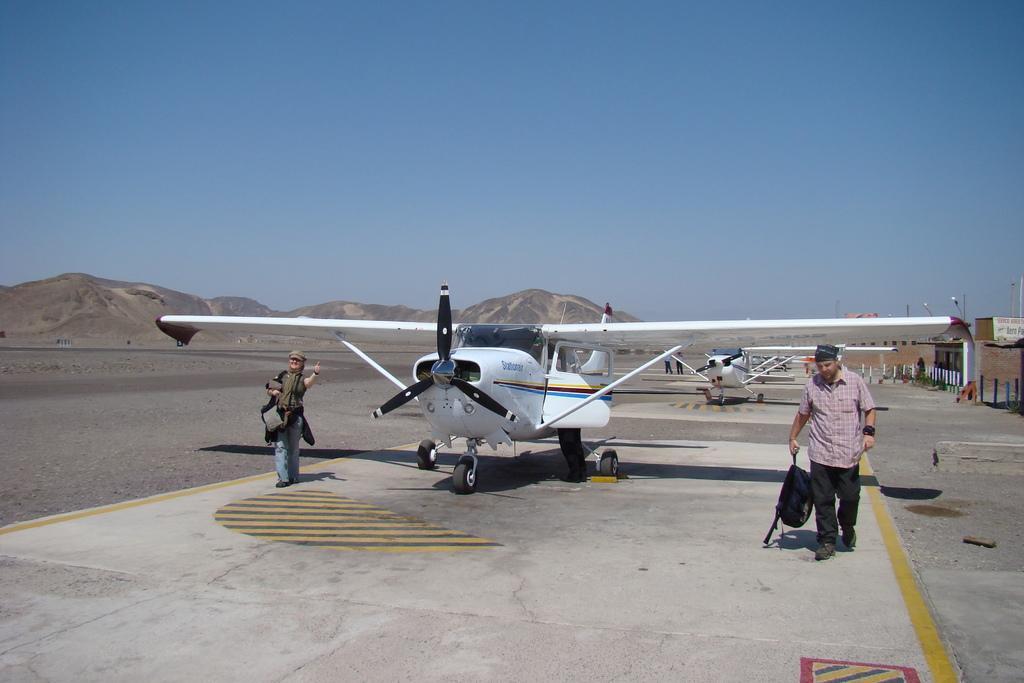How would you summarize this image in a sentence or two? In this picture there is an airplane which is in white color on the runway. There are two members on either sides of this airplane. In the background there is another airplane. We can observe hills here. There is a sky. 